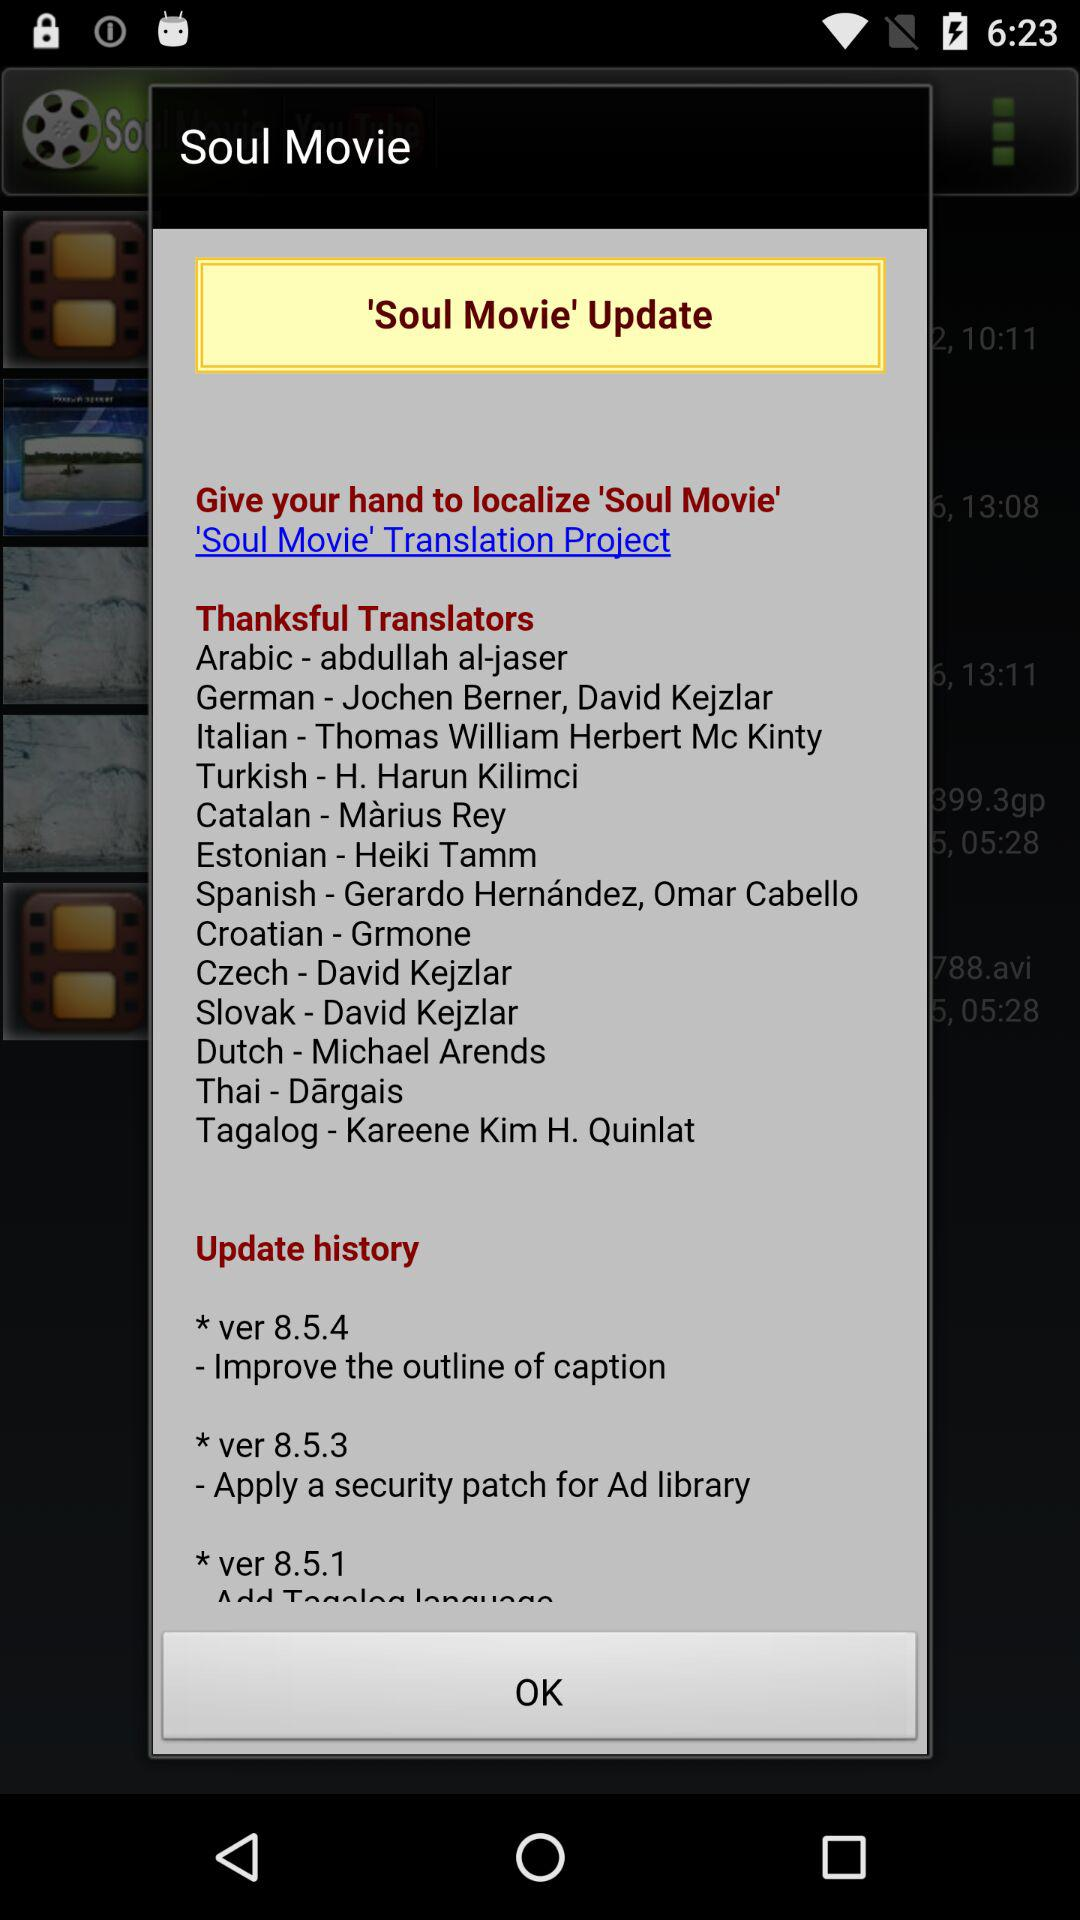What is the title of the movie? The title of the movie is Soul. 